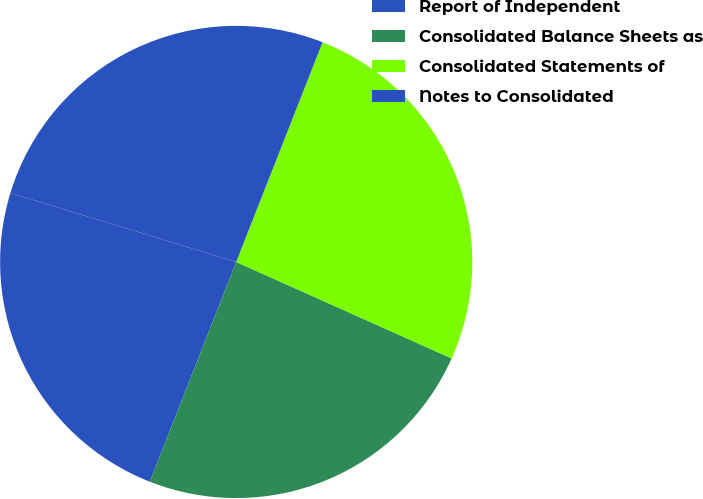Convert chart to OTSL. <chart><loc_0><loc_0><loc_500><loc_500><pie_chart><fcel>Report of Independent<fcel>Consolidated Balance Sheets as<fcel>Consolidated Statements of<fcel>Notes to Consolidated<nl><fcel>23.76%<fcel>24.26%<fcel>25.74%<fcel>26.24%<nl></chart> 